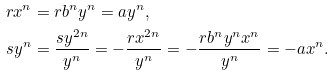Convert formula to latex. <formula><loc_0><loc_0><loc_500><loc_500>r x ^ { n } & = r b ^ { n } y ^ { n } = a y ^ { n } , \\ s y ^ { n } & = \frac { s y ^ { 2 n } } { y ^ { n } } = - \frac { r x ^ { 2 n } } { y ^ { n } } = - \frac { r b ^ { n } y ^ { n } x ^ { n } } { y ^ { n } } = - a x ^ { n } .</formula> 